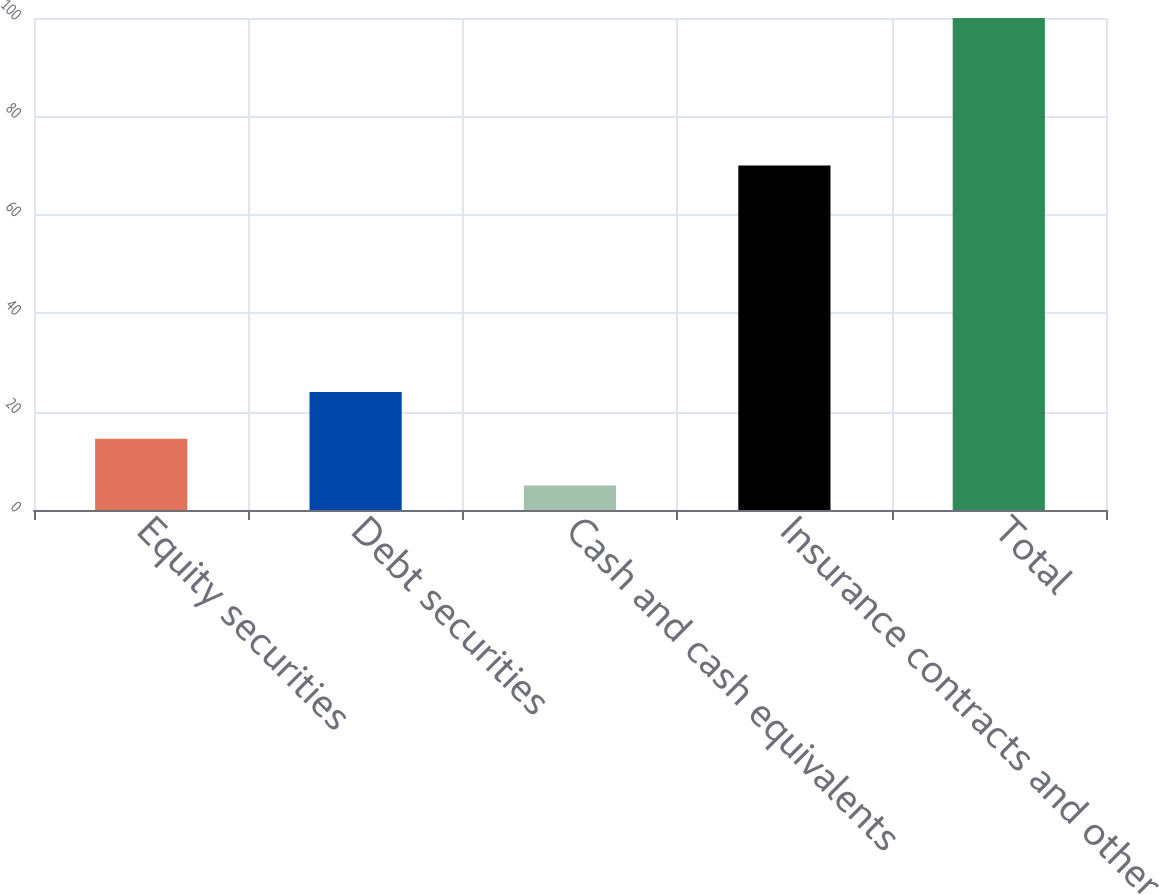Convert chart to OTSL. <chart><loc_0><loc_0><loc_500><loc_500><bar_chart><fcel>Equity securities<fcel>Debt securities<fcel>Cash and cash equivalents<fcel>Insurance contracts and other<fcel>Total<nl><fcel>14.5<fcel>24<fcel>5<fcel>70<fcel>100<nl></chart> 